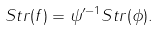<formula> <loc_0><loc_0><loc_500><loc_500>S t r ( f ) = \psi ^ { \prime - 1 } S t r ( \phi ) .</formula> 